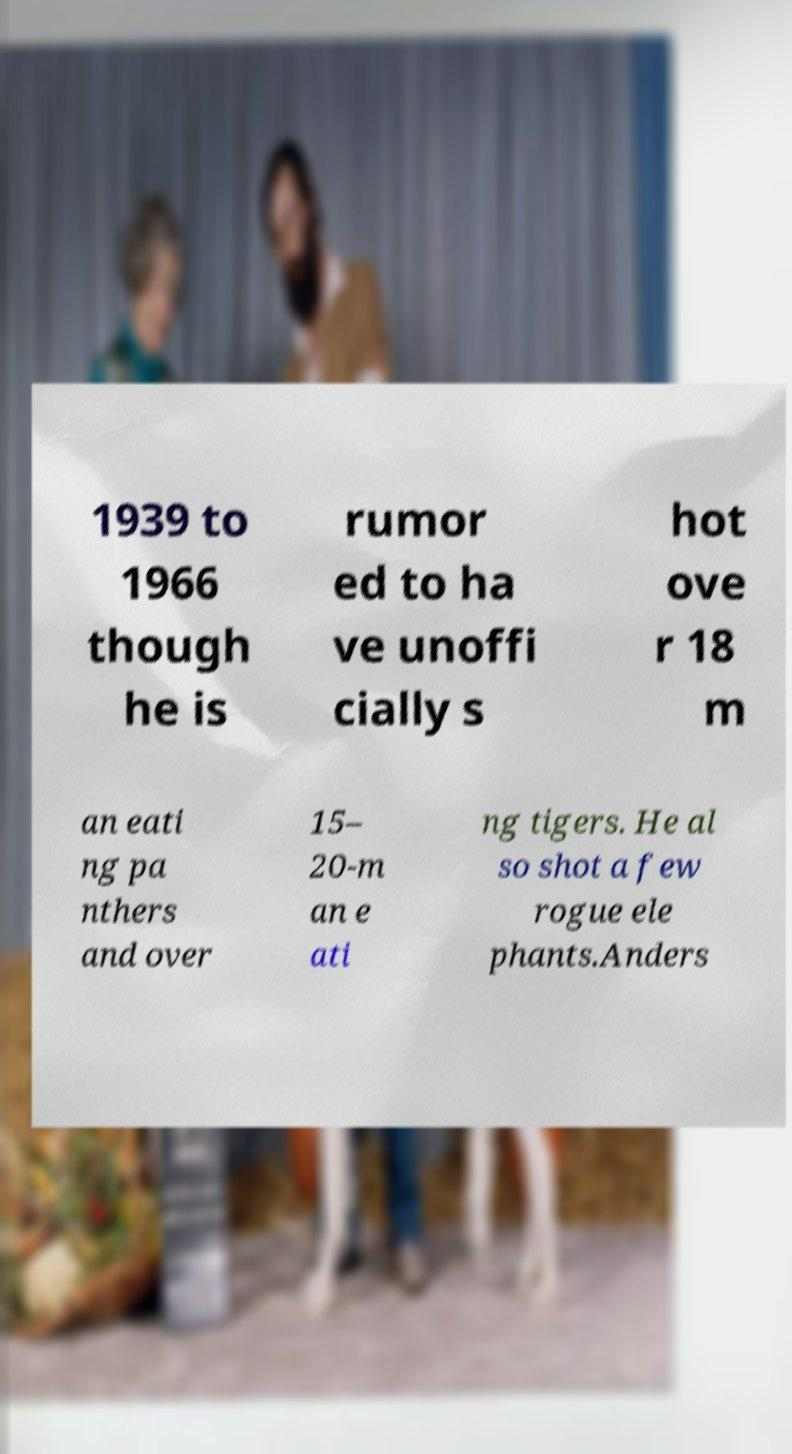Could you assist in decoding the text presented in this image and type it out clearly? 1939 to 1966 though he is rumor ed to ha ve unoffi cially s hot ove r 18 m an eati ng pa nthers and over 15– 20-m an e ati ng tigers. He al so shot a few rogue ele phants.Anders 